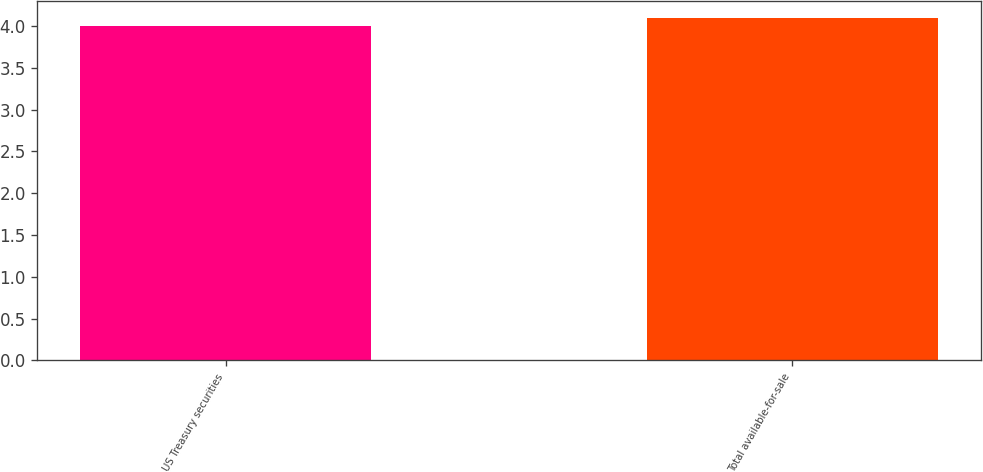<chart> <loc_0><loc_0><loc_500><loc_500><bar_chart><fcel>US Treasury securities<fcel>Total available-for-sale<nl><fcel>4<fcel>4.1<nl></chart> 